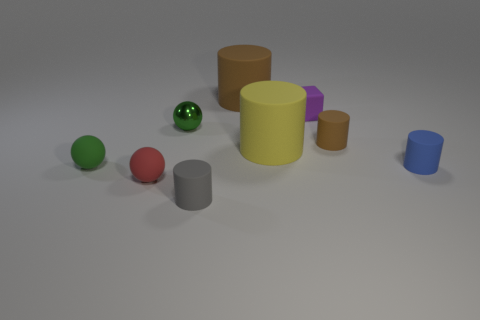Subtract all small green spheres. How many spheres are left? 1 Subtract all yellow cylinders. How many cylinders are left? 4 Subtract 1 cylinders. How many cylinders are left? 4 Subtract all red cylinders. Subtract all green spheres. How many cylinders are left? 5 Add 1 purple blocks. How many objects exist? 10 Subtract all cylinders. How many objects are left? 4 Add 5 small purple matte objects. How many small purple matte objects are left? 6 Add 4 cyan metal things. How many cyan metal things exist? 4 Subtract 0 green cylinders. How many objects are left? 9 Subtract all small gray rubber cylinders. Subtract all yellow cylinders. How many objects are left? 7 